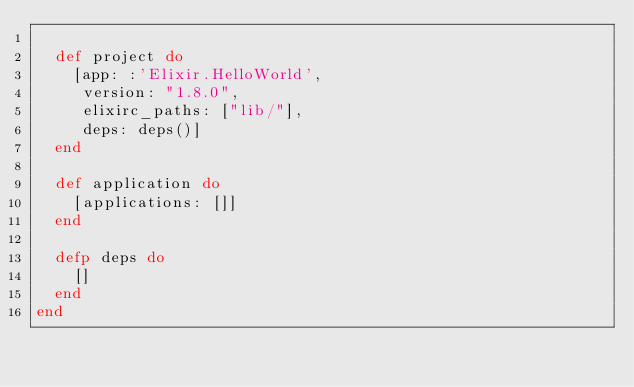<code> <loc_0><loc_0><loc_500><loc_500><_Elixir_>
  def project do
    [app: :'Elixir.HelloWorld',
     version: "1.8.0",
     elixirc_paths: ["lib/"],
     deps: deps()]
  end

  def application do
    [applications: []]
  end

  defp deps do
    []
  end
end
</code> 